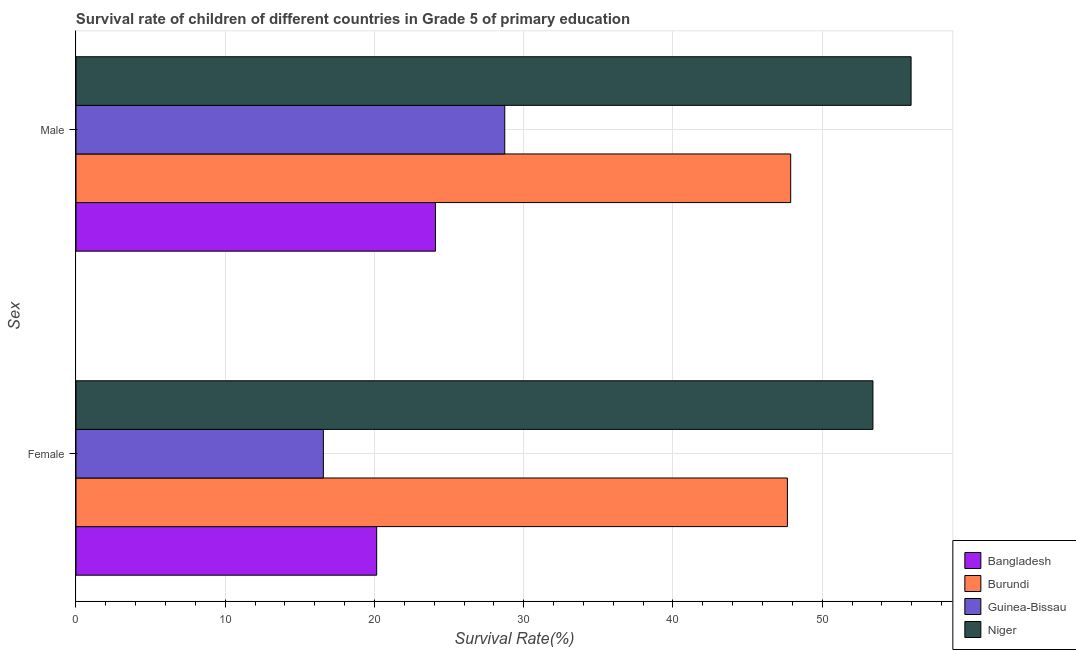How many groups of bars are there?
Ensure brevity in your answer.  2. Are the number of bars per tick equal to the number of legend labels?
Provide a short and direct response. Yes. Are the number of bars on each tick of the Y-axis equal?
Give a very brief answer. Yes. What is the label of the 2nd group of bars from the top?
Offer a very short reply. Female. What is the survival rate of female students in primary education in Burundi?
Offer a terse response. 47.67. Across all countries, what is the maximum survival rate of female students in primary education?
Provide a short and direct response. 53.4. Across all countries, what is the minimum survival rate of male students in primary education?
Your answer should be compact. 24.09. In which country was the survival rate of female students in primary education maximum?
Make the answer very short. Niger. In which country was the survival rate of female students in primary education minimum?
Your answer should be very brief. Guinea-Bissau. What is the total survival rate of male students in primary education in the graph?
Offer a terse response. 156.66. What is the difference between the survival rate of male students in primary education in Bangladesh and that in Guinea-Bissau?
Your response must be concise. -4.65. What is the difference between the survival rate of male students in primary education in Bangladesh and the survival rate of female students in primary education in Burundi?
Offer a very short reply. -23.59. What is the average survival rate of female students in primary education per country?
Offer a terse response. 34.45. What is the difference between the survival rate of female students in primary education and survival rate of male students in primary education in Niger?
Provide a succinct answer. -2.56. In how many countries, is the survival rate of male students in primary education greater than 34 %?
Offer a terse response. 2. What is the ratio of the survival rate of female students in primary education in Burundi to that in Guinea-Bissau?
Make the answer very short. 2.88. What does the 4th bar from the bottom in Male represents?
Provide a succinct answer. Niger. How many bars are there?
Your answer should be compact. 8. Are all the bars in the graph horizontal?
Provide a succinct answer. Yes. How many countries are there in the graph?
Offer a terse response. 4. What is the difference between two consecutive major ticks on the X-axis?
Your answer should be very brief. 10. Does the graph contain any zero values?
Your answer should be very brief. No. Does the graph contain grids?
Give a very brief answer. Yes. Where does the legend appear in the graph?
Provide a short and direct response. Bottom right. How many legend labels are there?
Make the answer very short. 4. What is the title of the graph?
Ensure brevity in your answer.  Survival rate of children of different countries in Grade 5 of primary education. Does "Ethiopia" appear as one of the legend labels in the graph?
Provide a short and direct response. No. What is the label or title of the X-axis?
Your answer should be compact. Survival Rate(%). What is the label or title of the Y-axis?
Provide a short and direct response. Sex. What is the Survival Rate(%) in Bangladesh in Female?
Provide a succinct answer. 20.15. What is the Survival Rate(%) of Burundi in Female?
Offer a terse response. 47.67. What is the Survival Rate(%) of Guinea-Bissau in Female?
Provide a succinct answer. 16.58. What is the Survival Rate(%) in Niger in Female?
Make the answer very short. 53.4. What is the Survival Rate(%) in Bangladesh in Male?
Make the answer very short. 24.09. What is the Survival Rate(%) of Burundi in Male?
Your answer should be compact. 47.89. What is the Survival Rate(%) in Guinea-Bissau in Male?
Offer a very short reply. 28.73. What is the Survival Rate(%) in Niger in Male?
Offer a terse response. 55.96. Across all Sex, what is the maximum Survival Rate(%) of Bangladesh?
Provide a short and direct response. 24.09. Across all Sex, what is the maximum Survival Rate(%) of Burundi?
Make the answer very short. 47.89. Across all Sex, what is the maximum Survival Rate(%) of Guinea-Bissau?
Your answer should be very brief. 28.73. Across all Sex, what is the maximum Survival Rate(%) of Niger?
Make the answer very short. 55.96. Across all Sex, what is the minimum Survival Rate(%) of Bangladesh?
Your answer should be very brief. 20.15. Across all Sex, what is the minimum Survival Rate(%) in Burundi?
Keep it short and to the point. 47.67. Across all Sex, what is the minimum Survival Rate(%) of Guinea-Bissau?
Ensure brevity in your answer.  16.58. Across all Sex, what is the minimum Survival Rate(%) of Niger?
Give a very brief answer. 53.4. What is the total Survival Rate(%) in Bangladesh in the graph?
Your answer should be very brief. 44.23. What is the total Survival Rate(%) in Burundi in the graph?
Give a very brief answer. 95.56. What is the total Survival Rate(%) in Guinea-Bissau in the graph?
Your answer should be very brief. 45.31. What is the total Survival Rate(%) of Niger in the graph?
Provide a short and direct response. 109.36. What is the difference between the Survival Rate(%) of Bangladesh in Female and that in Male?
Offer a very short reply. -3.94. What is the difference between the Survival Rate(%) in Burundi in Female and that in Male?
Offer a very short reply. -0.22. What is the difference between the Survival Rate(%) in Guinea-Bissau in Female and that in Male?
Provide a succinct answer. -12.15. What is the difference between the Survival Rate(%) of Niger in Female and that in Male?
Provide a succinct answer. -2.56. What is the difference between the Survival Rate(%) of Bangladesh in Female and the Survival Rate(%) of Burundi in Male?
Make the answer very short. -27.74. What is the difference between the Survival Rate(%) in Bangladesh in Female and the Survival Rate(%) in Guinea-Bissau in Male?
Keep it short and to the point. -8.58. What is the difference between the Survival Rate(%) of Bangladesh in Female and the Survival Rate(%) of Niger in Male?
Keep it short and to the point. -35.81. What is the difference between the Survival Rate(%) in Burundi in Female and the Survival Rate(%) in Guinea-Bissau in Male?
Provide a succinct answer. 18.94. What is the difference between the Survival Rate(%) in Burundi in Female and the Survival Rate(%) in Niger in Male?
Provide a succinct answer. -8.29. What is the difference between the Survival Rate(%) in Guinea-Bissau in Female and the Survival Rate(%) in Niger in Male?
Give a very brief answer. -39.38. What is the average Survival Rate(%) in Bangladesh per Sex?
Give a very brief answer. 22.12. What is the average Survival Rate(%) in Burundi per Sex?
Make the answer very short. 47.78. What is the average Survival Rate(%) in Guinea-Bissau per Sex?
Provide a short and direct response. 22.65. What is the average Survival Rate(%) of Niger per Sex?
Provide a short and direct response. 54.68. What is the difference between the Survival Rate(%) in Bangladesh and Survival Rate(%) in Burundi in Female?
Ensure brevity in your answer.  -27.52. What is the difference between the Survival Rate(%) of Bangladesh and Survival Rate(%) of Guinea-Bissau in Female?
Offer a terse response. 3.57. What is the difference between the Survival Rate(%) of Bangladesh and Survival Rate(%) of Niger in Female?
Give a very brief answer. -33.25. What is the difference between the Survival Rate(%) in Burundi and Survival Rate(%) in Guinea-Bissau in Female?
Your answer should be compact. 31.09. What is the difference between the Survival Rate(%) of Burundi and Survival Rate(%) of Niger in Female?
Give a very brief answer. -5.73. What is the difference between the Survival Rate(%) in Guinea-Bissau and Survival Rate(%) in Niger in Female?
Provide a short and direct response. -36.83. What is the difference between the Survival Rate(%) in Bangladesh and Survival Rate(%) in Burundi in Male?
Give a very brief answer. -23.81. What is the difference between the Survival Rate(%) in Bangladesh and Survival Rate(%) in Guinea-Bissau in Male?
Offer a very short reply. -4.65. What is the difference between the Survival Rate(%) in Bangladesh and Survival Rate(%) in Niger in Male?
Offer a terse response. -31.87. What is the difference between the Survival Rate(%) in Burundi and Survival Rate(%) in Guinea-Bissau in Male?
Ensure brevity in your answer.  19.16. What is the difference between the Survival Rate(%) in Burundi and Survival Rate(%) in Niger in Male?
Provide a succinct answer. -8.07. What is the difference between the Survival Rate(%) in Guinea-Bissau and Survival Rate(%) in Niger in Male?
Keep it short and to the point. -27.23. What is the ratio of the Survival Rate(%) in Bangladesh in Female to that in Male?
Offer a terse response. 0.84. What is the ratio of the Survival Rate(%) of Burundi in Female to that in Male?
Your response must be concise. 1. What is the ratio of the Survival Rate(%) in Guinea-Bissau in Female to that in Male?
Make the answer very short. 0.58. What is the ratio of the Survival Rate(%) of Niger in Female to that in Male?
Provide a short and direct response. 0.95. What is the difference between the highest and the second highest Survival Rate(%) in Bangladesh?
Your answer should be very brief. 3.94. What is the difference between the highest and the second highest Survival Rate(%) in Burundi?
Offer a very short reply. 0.22. What is the difference between the highest and the second highest Survival Rate(%) in Guinea-Bissau?
Offer a very short reply. 12.15. What is the difference between the highest and the second highest Survival Rate(%) of Niger?
Provide a succinct answer. 2.56. What is the difference between the highest and the lowest Survival Rate(%) of Bangladesh?
Provide a succinct answer. 3.94. What is the difference between the highest and the lowest Survival Rate(%) in Burundi?
Your answer should be compact. 0.22. What is the difference between the highest and the lowest Survival Rate(%) of Guinea-Bissau?
Ensure brevity in your answer.  12.15. What is the difference between the highest and the lowest Survival Rate(%) in Niger?
Provide a short and direct response. 2.56. 